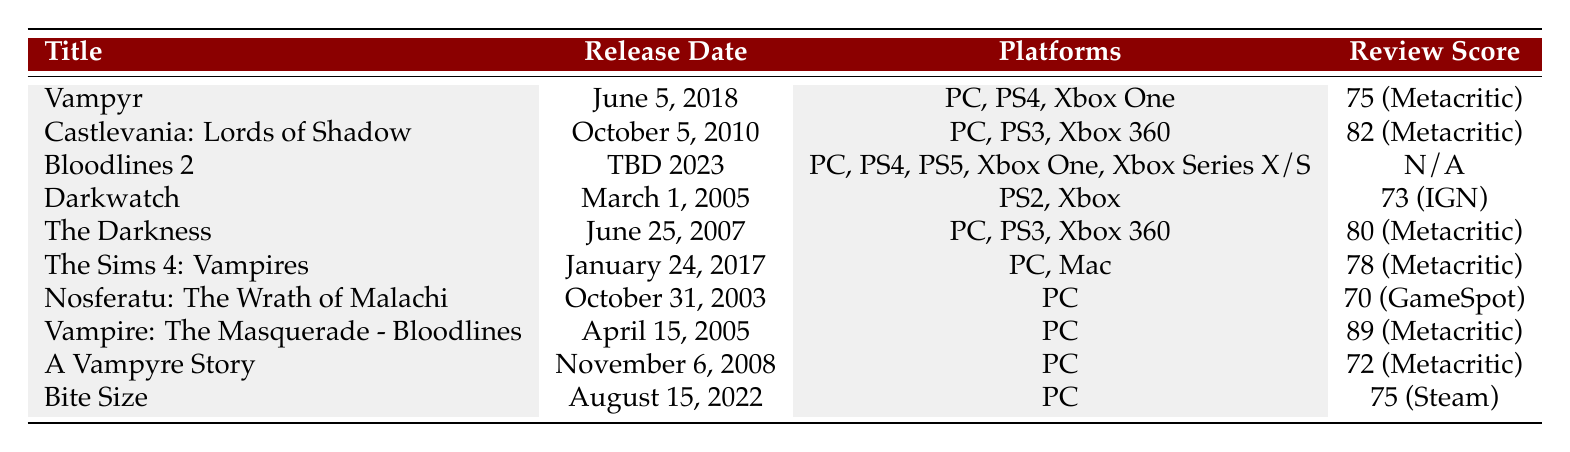What is the release date of "Vampire: The Masquerade - Bloodlines"? The table lists "Vampire: The Masquerade - Bloodlines" with a release date of April 15, 2005.
Answer: April 15, 2005 Which game has the highest critical review score, and what is that score? The table shows that "Vampire: The Masquerade - Bloodlines" has the highest score of 89 according to Metacritic.
Answer: Vampire: The Masquerade - Bloodlines, 89 Is "Bloodlines 2" available on Xbox platforms? The table states that "Bloodlines 2" is available on Xbox One and Xbox Series X/S, indicating that it is indeed available on Xbox platforms.
Answer: Yes What is the average critical review score of the games listed in the table, excluding "Bloodlines 2"? To find the average, we calculate the sum of the review scores (75 + 82 + 73 + 80 + 78 + 70 + 89 + 72 + 75) = 619. There are 9 games listed, but "Bloodlines 2" does not have a score, so we use 8 for our average calculation. The average is 619/8 = 77.375, which we can round to approximately 77.4.
Answer: 77.4 Which game has the lowest critical review score, and how low is it? Looking through the table, "Nosferatu: The Wrath of Malachi" has the lowest score at 70 according to GameSpot.
Answer: Nosferatu: The Wrath of Malachi, 70 Does "A Vampyre Story" have a review score higher than 75? The table indicates that "A Vampyre Story" has a score of 72, which is lower than 75, so the answer is no.
Answer: No How many platforms does "The Sims 4: Vampires" support? The table lists "The Sims 4: Vampires" as supporting two platforms: PC and Mac.
Answer: 2 Is there any game in the list that was released after 2018 and has a critical review score? The table shows "Bloodlines 2" was released with a TBD 2023 date and does not have a review score, hence there are no games released after 2018 with a score.
Answer: No What is the total number of platforms supported by all games listed? By adding the unique platforms for each game, we find the total number of platforms: "Vampyr" (3), "Castlevania: Lords of Shadow" (3), "Bloodlines 2" (5), "Darkwatch" (2), "The Darkness" (3), "The Sims 4: Vampires" (2), "Nosferatu: The Wrath of Malachi" (1), "Vampire: The Masquerade - Bloodlines" (1), "A Vampyre Story" (1), "Bite Size" (1). The total unique platforms are 3 + 3 + 5 + 2 + 3 + 2 + 1 + 1 + 1 + 1 = 22. However, unique platforms consolidate duplicates, showing a count of 8 unique platforms: PC, PS4, Xbox One, Xbox 360, PS2, PS3, Mac, and Xbox Series X/S.
Answer: 8 